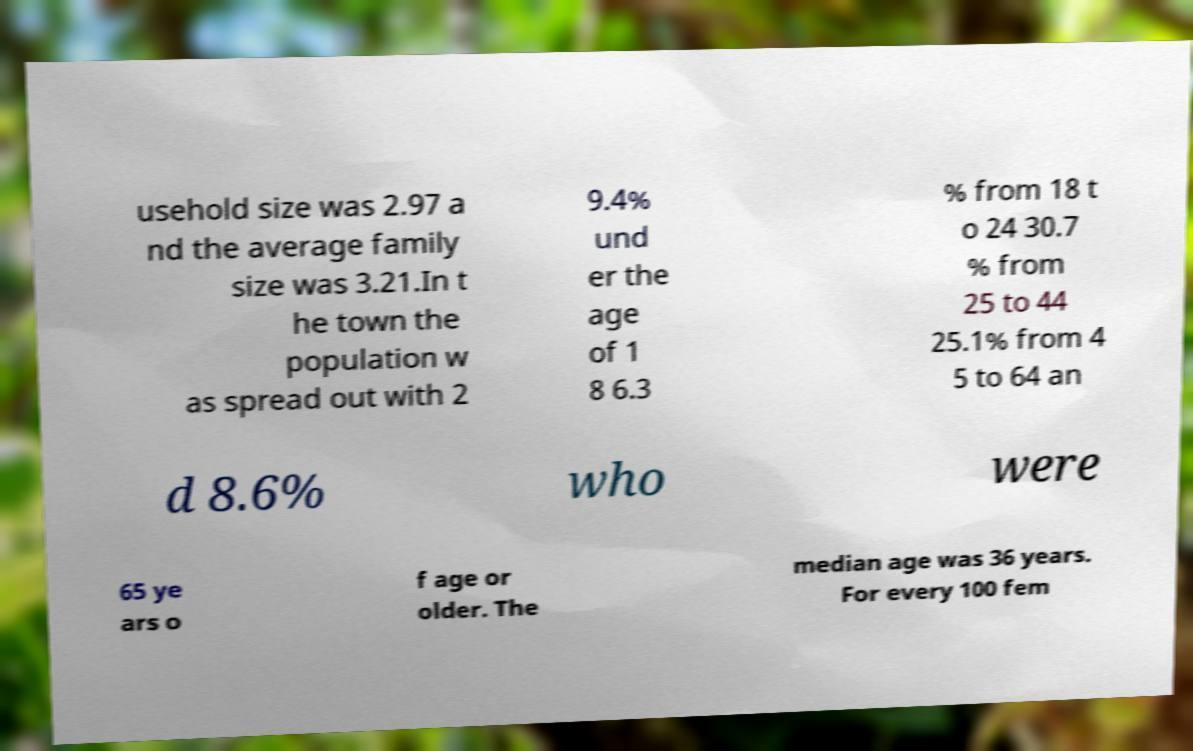Could you assist in decoding the text presented in this image and type it out clearly? usehold size was 2.97 a nd the average family size was 3.21.In t he town the population w as spread out with 2 9.4% und er the age of 1 8 6.3 % from 18 t o 24 30.7 % from 25 to 44 25.1% from 4 5 to 64 an d 8.6% who were 65 ye ars o f age or older. The median age was 36 years. For every 100 fem 